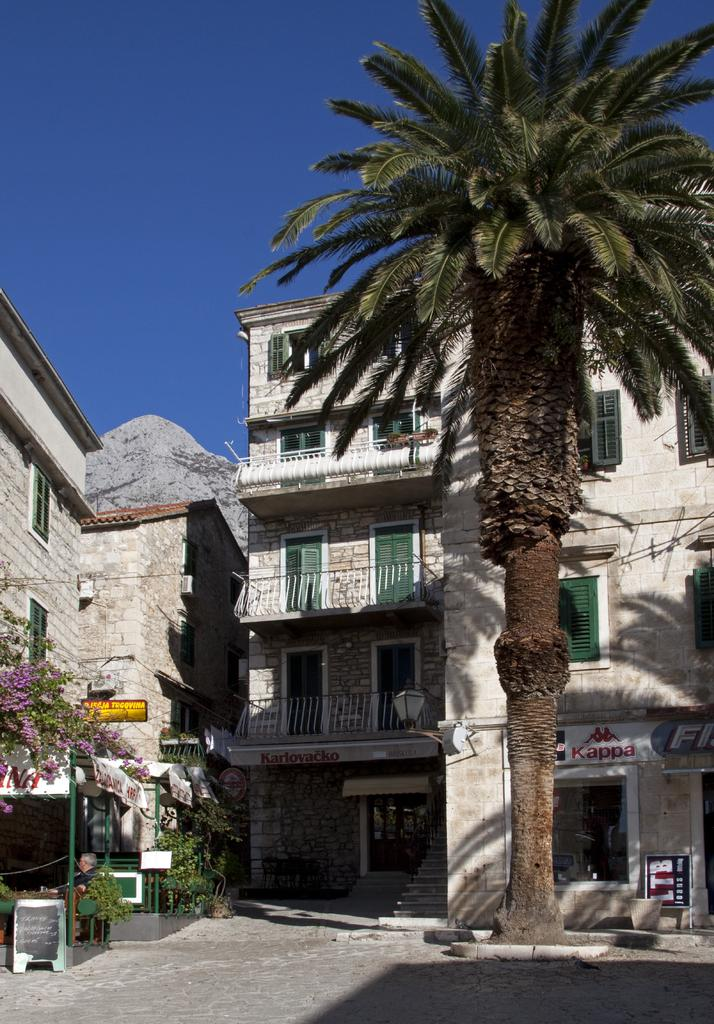<image>
Relay a brief, clear account of the picture shown. a palm tree in front of a shop with Kappa on it 